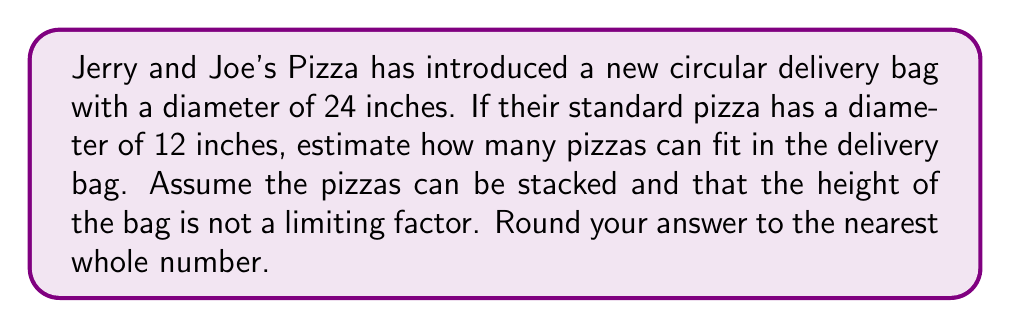Give your solution to this math problem. Let's approach this step-by-step:

1) First, we need to calculate the areas of both the delivery bag and a single pizza.

2) For a circle, the area is given by the formula: $A = \pi r^2$, where $r$ is the radius.

3) For the delivery bag:
   Diameter = 24 inches, so radius = 12 inches
   Area of bag = $\pi (12)^2 = 144\pi$ square inches

4) For a single pizza:
   Diameter = 12 inches, so radius = 6 inches
   Area of pizza = $\pi (6)^2 = 36\pi$ square inches

5) To estimate how many pizzas can fit, we divide the area of the bag by the area of a single pizza:

   $$\text{Number of pizzas} = \frac{\text{Area of bag}}{\text{Area of pizza}} = \frac{144\pi}{36\pi} = 4$$

6) Therefore, approximately 4 pizzas can fit in the delivery bag.

[asy]
size(200);
draw(circle((0,0),24), blue);
draw(circle((0,8),12), red);
draw(circle((0,-8),12), red);
draw(circle((8,0),12), red);
draw(circle((-8,0),12), red);
label("Delivery Bag", (0,-27), blue);
label("Pizza", (15,15), red);
[/asy]
Answer: 4 pizzas 